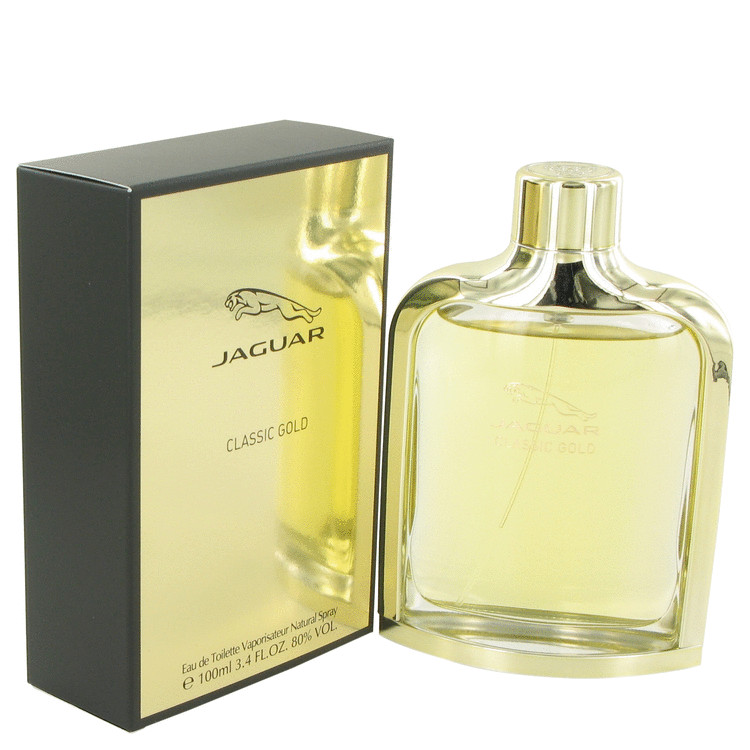What sensations or moods might the design and color scheme of this perfume evoke? The design and color scheme of this perfume are likely to evoke sensations and moods of luxury, elegance, and sophistication. The gold elements signify opulence and high quality, creating an impression of exclusivity and desirability. The contrasting matte black background adds a modern, understated charm, evoking feelings of refinement and timelessness. Together, these elements might make someone feel a sense of grandeur and confidence. The sleek, reflective nature of the gold also suggests a visual shimmer, which can evoke a feeling of celebration or special occasion. Can you describe a narrative in which this perfume plays a significant role in a person's life? Grace was about to step onto the stage for her first solo concert, a culmination of years of hard work and dedication to her art. Just before she left her dressing room, she reached for her go-to perfume, the classic gold bottle filled with an elegant, timeless scent. The luxurious packaging had been a gift from her mentor, a symbolic gesture of passing the torch. As she sprayed the perfume, the rich, sophisticated aroma filled the room, and she felt enveloped in a sense of confidence and calm. The scent felt like a protective talisman, reminding her of all her achievements and the elegance she aspired to embody. Every time she felt the soft whispers of the perfume during her performance, it reinforced her presence on stage, making her feel invincible. The perfume became an integral part of her rituals, a daily reminder of her journey and the person she had become. What imaginary world could this perfume belong to, considering its packaging and design? In an enchanting world where magic and elegance intertwined, there existed the Kingdom of Luminara. Here, every glittering star in the night sky was believed to be the soul of a luminous perfume, crafted by celestial artisans. Among these divine creations, the 'Golden Essence' stood out - a perfume encased in a bottle of liquid gold, surrounded by an aura of mysterious black. It was said that the 'Golden Essence' granted its wearer a captivating charm and an aura of regality. The kingdom’s royal families would gift this exquisite perfume to those who displayed valor and grace, enhancing their presence at grand celestial balls. Possessing the 'Golden Essence' was a mark of distinction, symbolizing one’s esteemed status in the magical society of Luminara. Realistically speaking, in which types of stores would you expect to find this perfume? You would likely find this perfume in high-end department stores, luxury boutique shops, and exclusive fragrance stores. It might also be available in select sections of upscale retail chains and specialty stores that focus on premium beauty products. Additionally, you might encounter it in duty-free shops at international airports, catering to travelers looking for luxurious and high-quality items. Some high-end online retailers and brand-specific e-commerce platforms would also carry this perfume, providing a convenient shopping experience for discerning customers. 